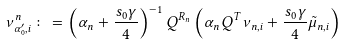Convert formula to latex. <formula><loc_0><loc_0><loc_500><loc_500>\nu _ { \alpha _ { 0 } ^ { \prime } , i } ^ { n } \colon = \left ( \alpha _ { n } + \frac { s _ { 0 } \gamma } { 4 } \right ) ^ { - 1 } Q ^ { R _ { n } } \left ( \alpha _ { n } Q ^ { T } \nu _ { n , i } + \frac { s _ { 0 } \gamma } { 4 } \tilde { \mu } _ { n , i } \right )</formula> 